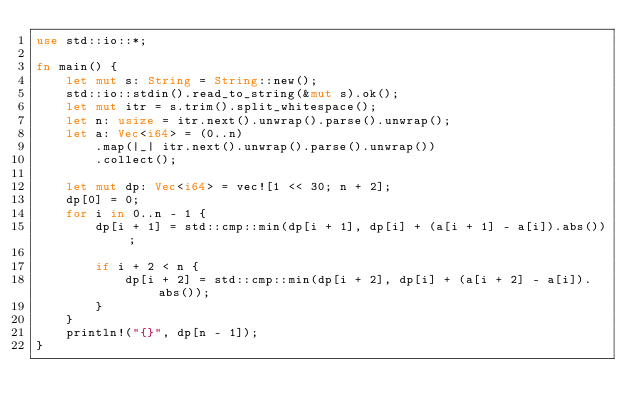<code> <loc_0><loc_0><loc_500><loc_500><_Rust_>use std::io::*;

fn main() {
    let mut s: String = String::new();
    std::io::stdin().read_to_string(&mut s).ok();
    let mut itr = s.trim().split_whitespace();
    let n: usize = itr.next().unwrap().parse().unwrap();
    let a: Vec<i64> = (0..n)
        .map(|_| itr.next().unwrap().parse().unwrap())
        .collect();

    let mut dp: Vec<i64> = vec![1 << 30; n + 2];
    dp[0] = 0;
    for i in 0..n - 1 {
        dp[i + 1] = std::cmp::min(dp[i + 1], dp[i] + (a[i + 1] - a[i]).abs());

        if i + 2 < n {
            dp[i + 2] = std::cmp::min(dp[i + 2], dp[i] + (a[i + 2] - a[i]).abs());
        }
    }
    println!("{}", dp[n - 1]);
}
</code> 